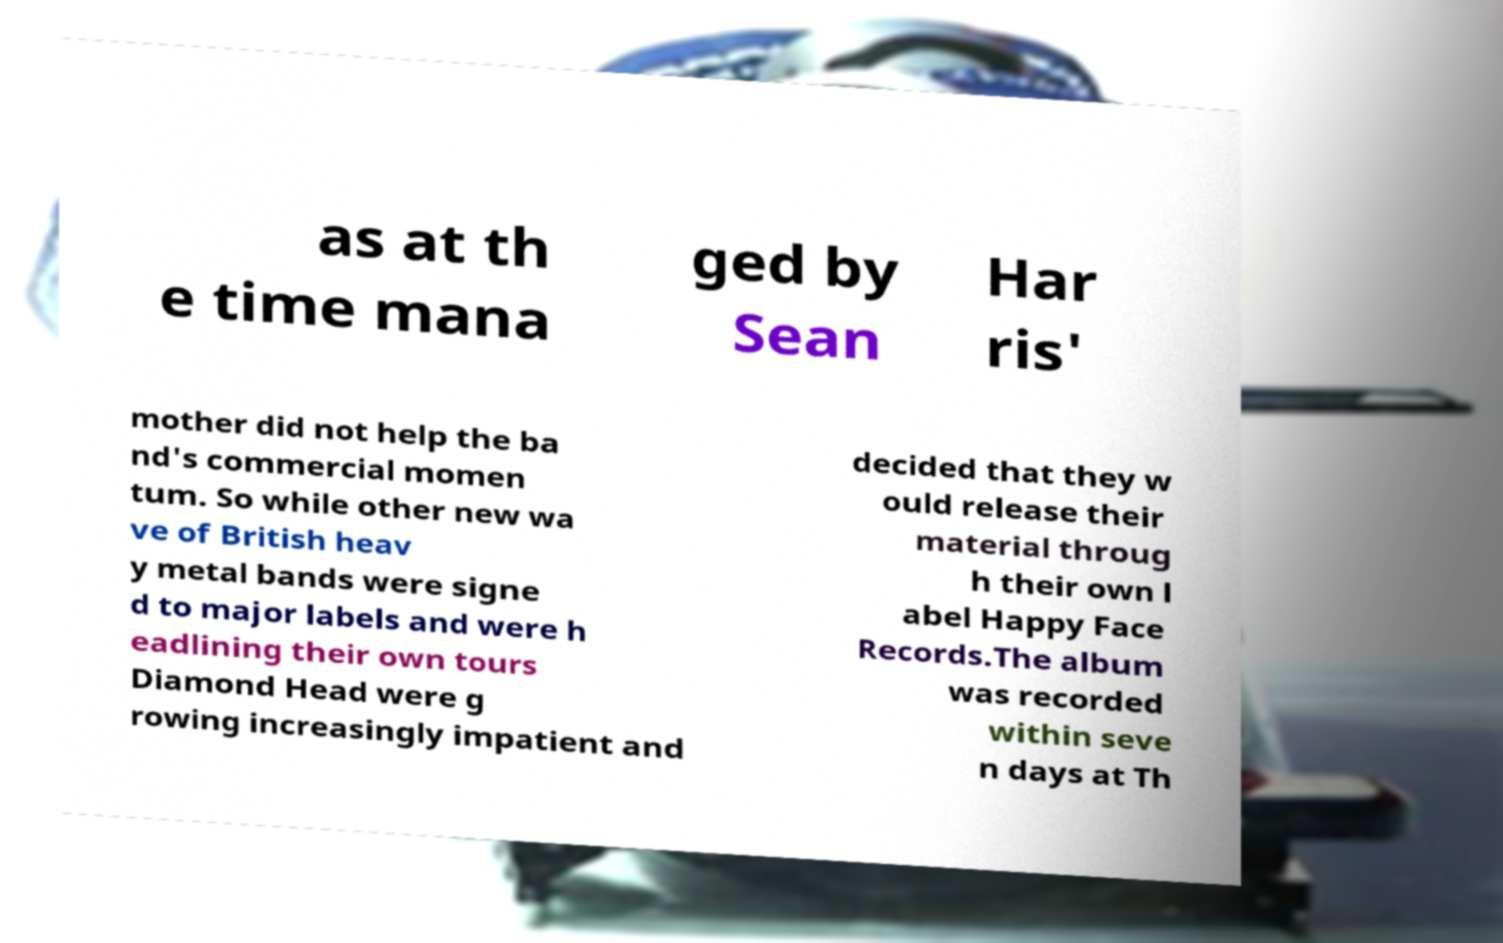Can you read and provide the text displayed in the image?This photo seems to have some interesting text. Can you extract and type it out for me? as at th e time mana ged by Sean Har ris' mother did not help the ba nd's commercial momen tum. So while other new wa ve of British heav y metal bands were signe d to major labels and were h eadlining their own tours Diamond Head were g rowing increasingly impatient and decided that they w ould release their material throug h their own l abel Happy Face Records.The album was recorded within seve n days at Th 